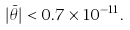<formula> <loc_0><loc_0><loc_500><loc_500>| \bar { \theta } | < 0 . 7 \times 1 0 ^ { - 1 1 } .</formula> 